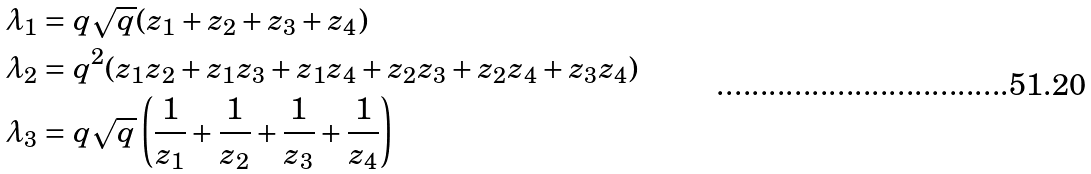Convert formula to latex. <formula><loc_0><loc_0><loc_500><loc_500>\lambda _ { 1 } & = q \sqrt { q } ( z _ { 1 } + z _ { 2 } + z _ { 3 } + z _ { 4 } ) \\ \lambda _ { 2 } & = q ^ { 2 } ( z _ { 1 } z _ { 2 } + z _ { 1 } z _ { 3 } + z _ { 1 } z _ { 4 } + z _ { 2 } z _ { 3 } + z _ { 2 } z _ { 4 } + z _ { 3 } z _ { 4 } ) \\ \lambda _ { 3 } & = q \sqrt { q } \left ( \frac { 1 } { z _ { 1 } } + \frac { 1 } { z _ { 2 } } + \frac { 1 } { z _ { 3 } } + \frac { 1 } { z _ { 4 } } \right )</formula> 